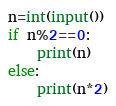Convert code to text. <code><loc_0><loc_0><loc_500><loc_500><_Python_>n=int(input())
if n%2==0:
    print(n)
else:
    print(n*2)</code> 